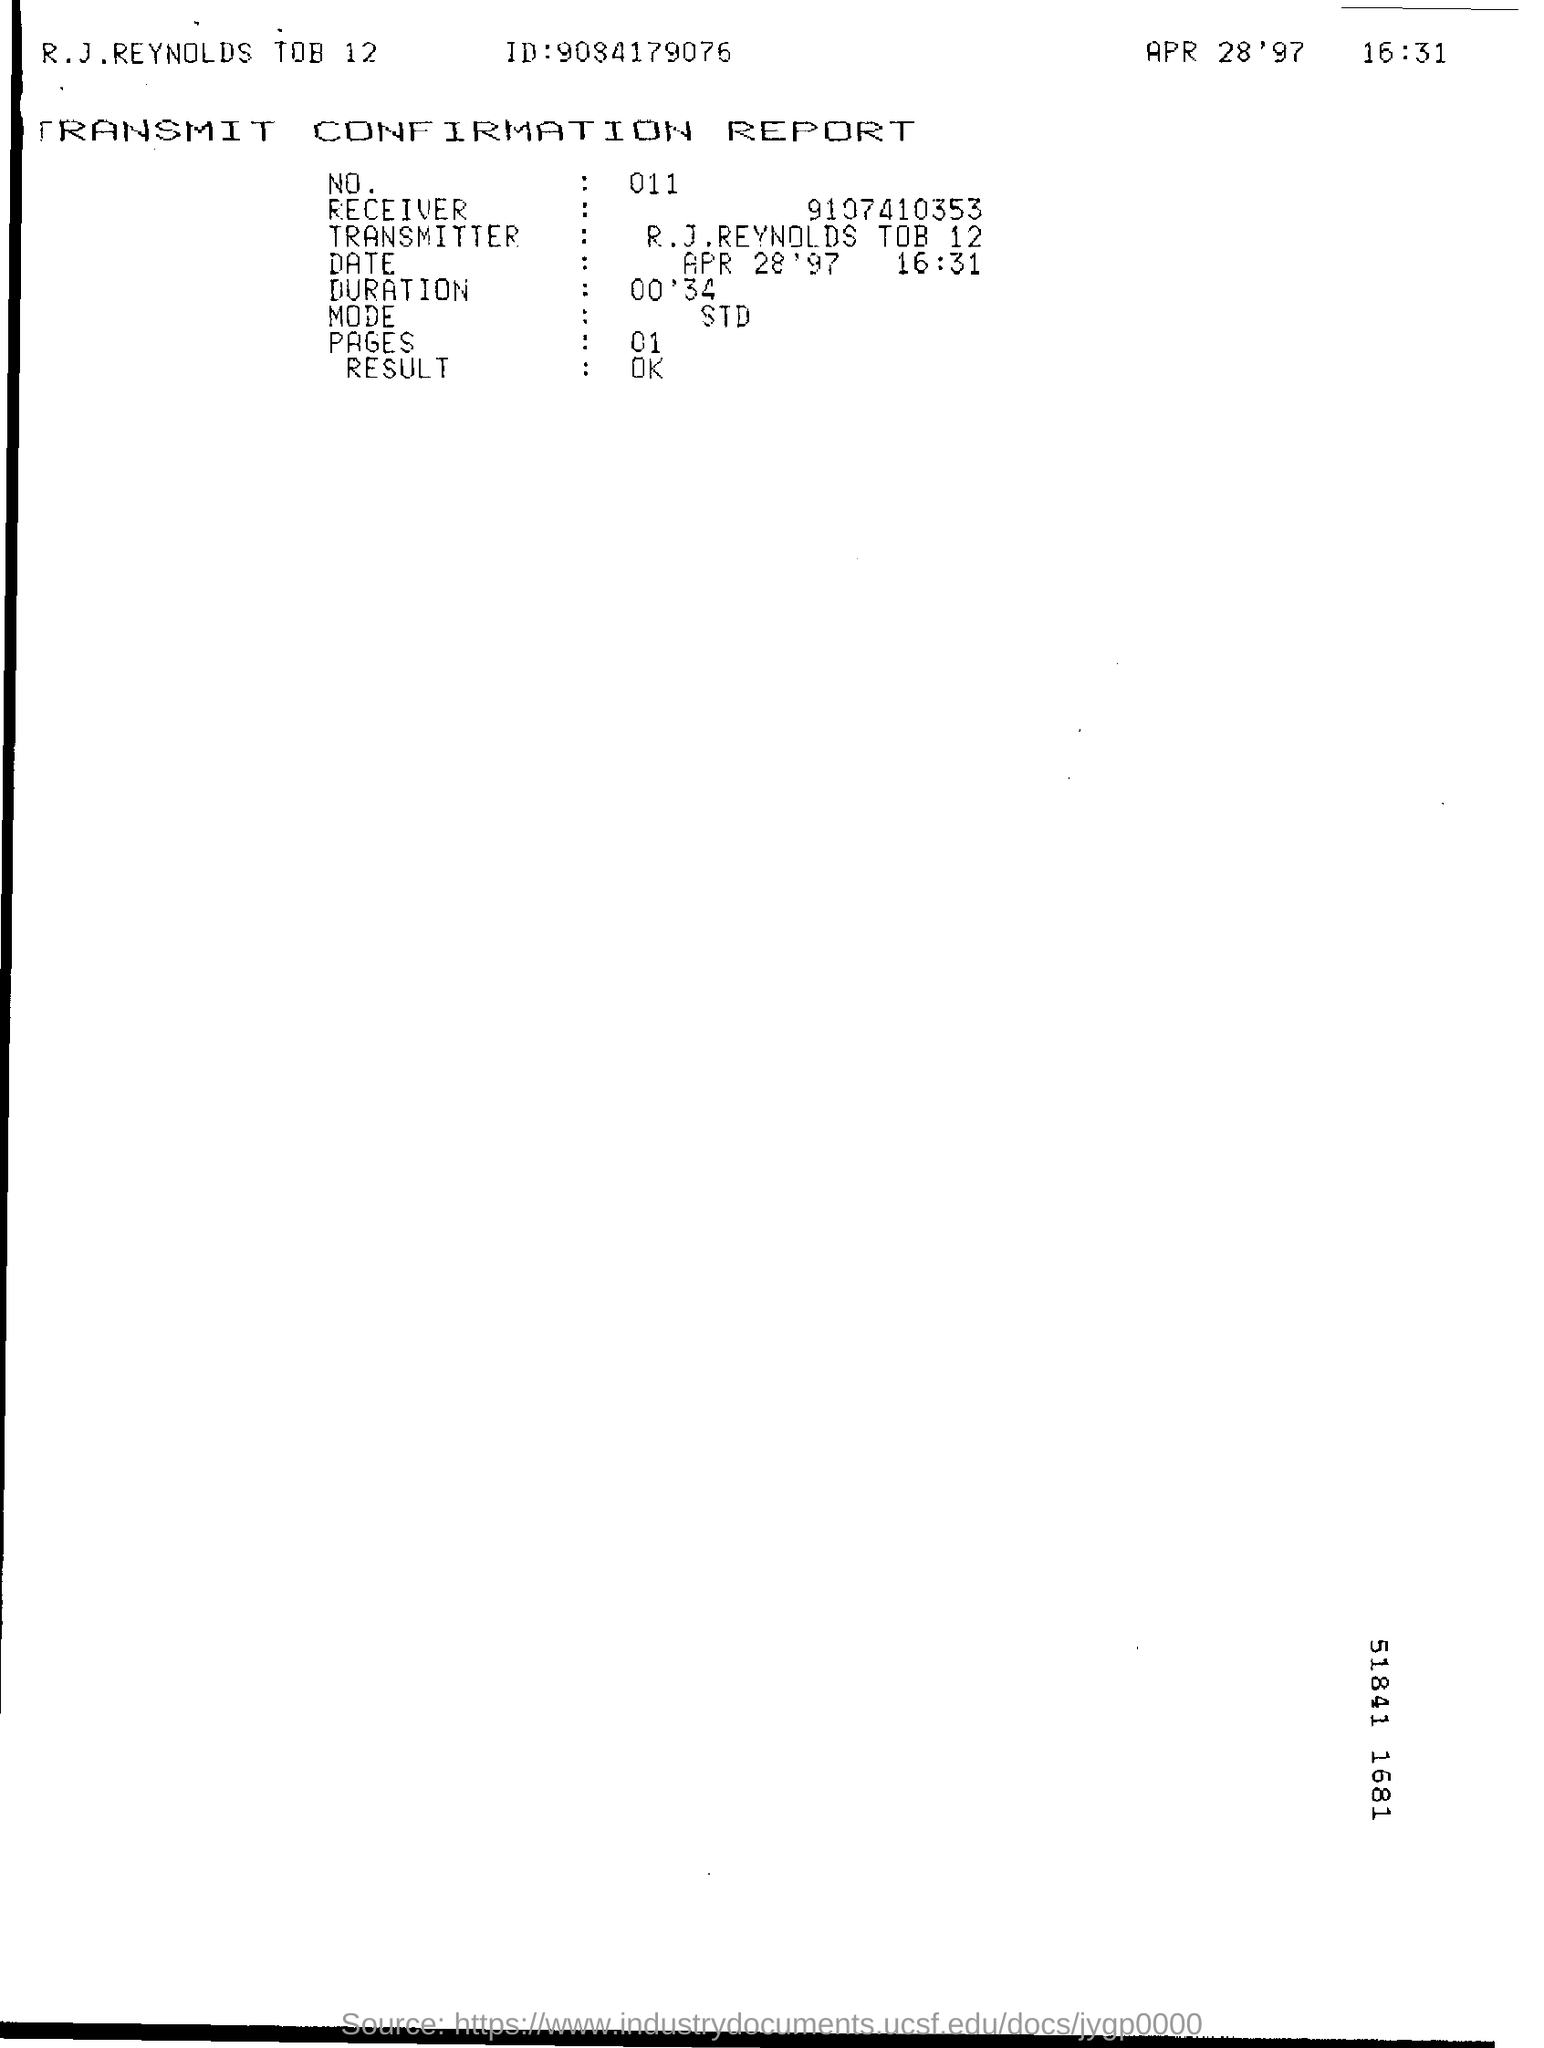What type of documentation is this?
Give a very brief answer. Transmit Confirmation Report. What is the number on report?
Offer a very short reply. 011. What is the ID mentioned in the report?
Provide a short and direct response. 9084179076. What is the mode mentioned?
Provide a short and direct response. STD. When is the document dated?
Make the answer very short. APR 28'97. 